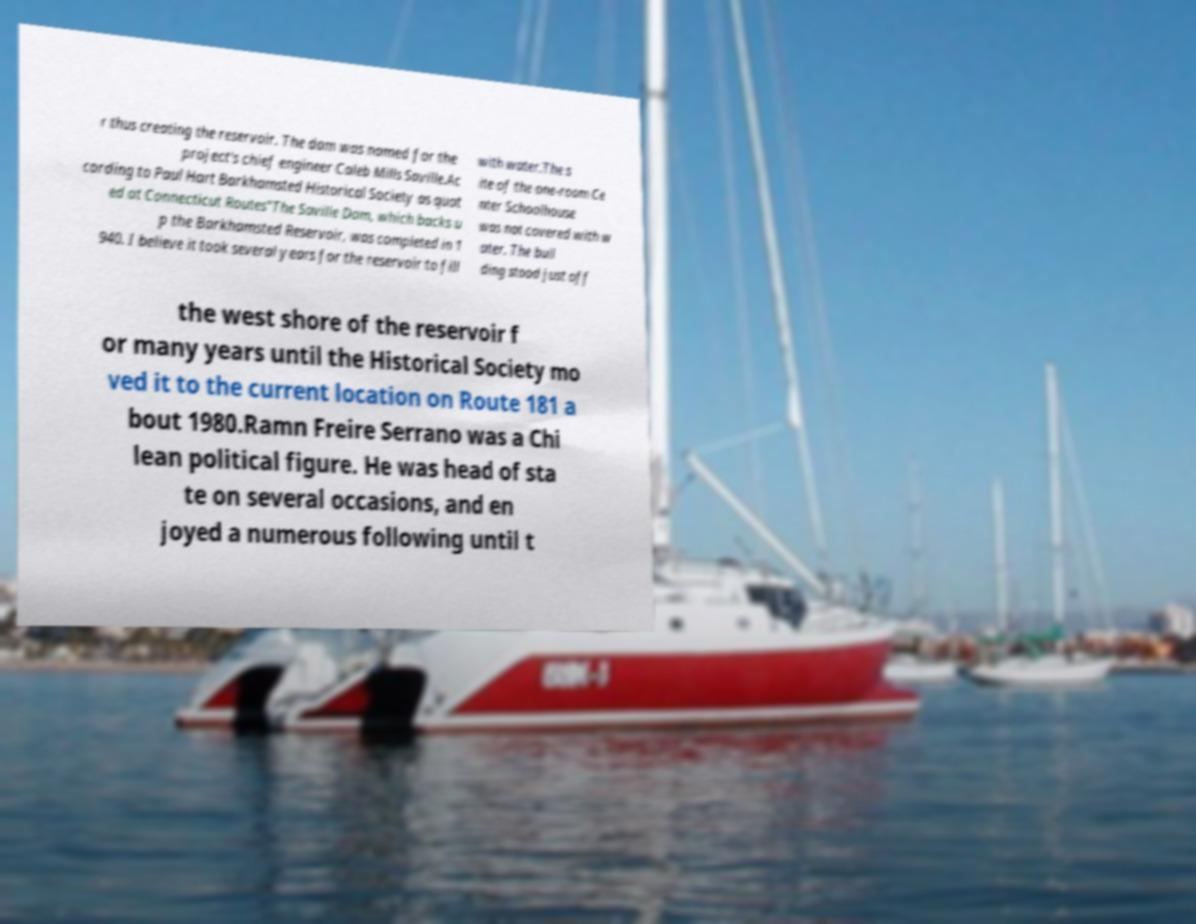Could you assist in decoding the text presented in this image and type it out clearly? r thus creating the reservoir. The dam was named for the project's chief engineer Caleb Mills Saville.Ac cording to Paul Hart Barkhamsted Historical Society as quot ed at Connecticut Routes"The Saville Dam, which backs u p the Barkhamsted Reservoir, was completed in 1 940. I believe it took several years for the reservoir to fill with water.The s ite of the one-room Ce nter Schoolhouse was not covered with w ater. The buil ding stood just off the west shore of the reservoir f or many years until the Historical Society mo ved it to the current location on Route 181 a bout 1980.Ramn Freire Serrano was a Chi lean political figure. He was head of sta te on several occasions, and en joyed a numerous following until t 